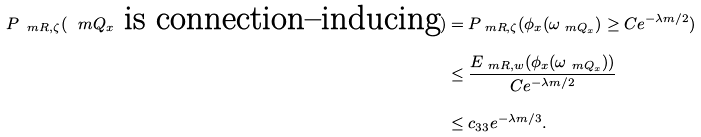<formula> <loc_0><loc_0><loc_500><loc_500>P _ { \ m R , \zeta } ( \ m Q _ { x } \text { is connection--inducing} ) & = P _ { \ m R , \zeta } ( \phi _ { x } ( \omega _ { \ m Q _ { x } } ) \geq C e ^ { - \lambda m / 2 } ) \\ & \leq \frac { E _ { \ m R , w } ( \phi _ { x } ( \omega _ { \ m Q _ { x } } ) ) } { C e ^ { - \lambda m / 2 } } \\ & \leq c _ { 3 3 } e ^ { - \lambda m / 3 } .</formula> 